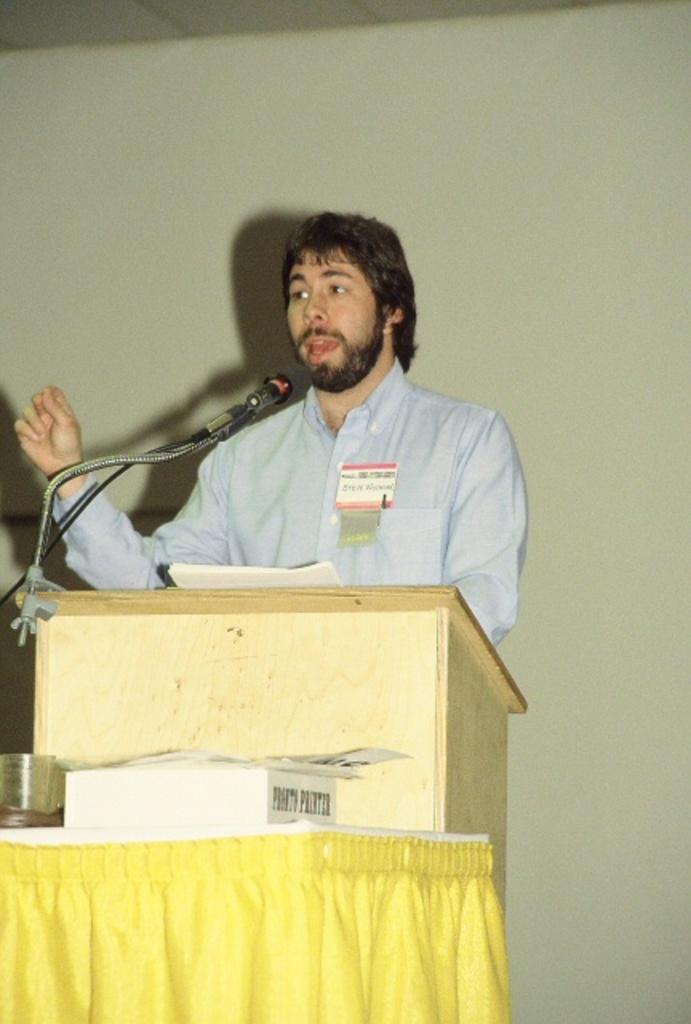In one or two sentences, can you explain what this image depicts? In this image I can see there is a man standing behind the podium and there is a microphone attached to it. There is a table and there are few objects placed on it. In the backdrop there is a wall. 